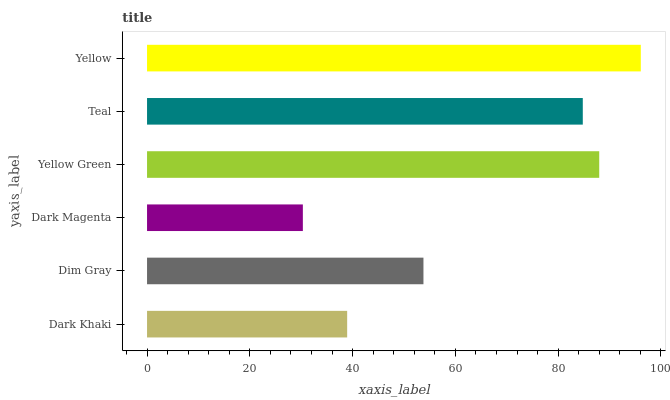Is Dark Magenta the minimum?
Answer yes or no. Yes. Is Yellow the maximum?
Answer yes or no. Yes. Is Dim Gray the minimum?
Answer yes or no. No. Is Dim Gray the maximum?
Answer yes or no. No. Is Dim Gray greater than Dark Khaki?
Answer yes or no. Yes. Is Dark Khaki less than Dim Gray?
Answer yes or no. Yes. Is Dark Khaki greater than Dim Gray?
Answer yes or no. No. Is Dim Gray less than Dark Khaki?
Answer yes or no. No. Is Teal the high median?
Answer yes or no. Yes. Is Dim Gray the low median?
Answer yes or no. Yes. Is Dark Magenta the high median?
Answer yes or no. No. Is Yellow the low median?
Answer yes or no. No. 